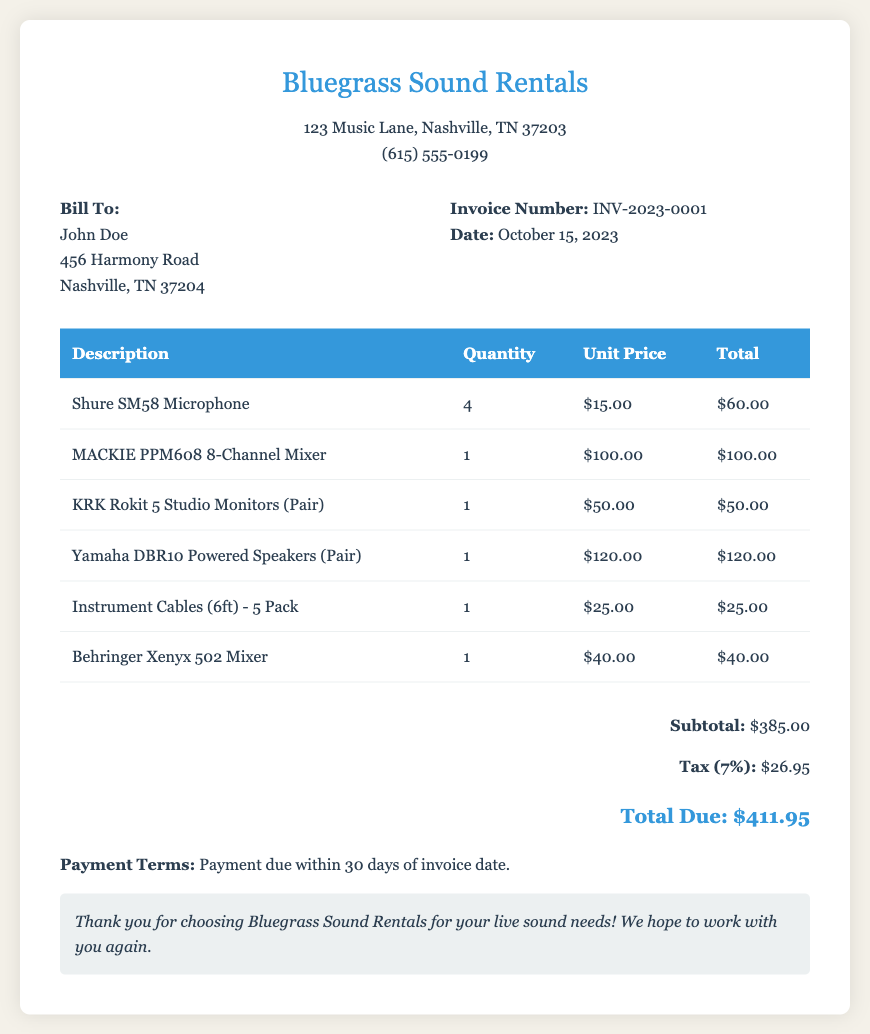What is the business name? The business name is prominently displayed at the top of the document.
Answer: Bluegrass Sound Rentals What is the invoice number? The invoice number is indicated in the invoice details section.
Answer: INV-2023-0001 What is the date of the invoice? The date is found alongside the invoice number in the invoice details section.
Answer: October 15, 2023 How many Shure SM58 Microphones were rented? This information is listed in the itemized charges table under quantity for Shure SM58 Microphone.
Answer: 4 What is the total due amount? The total due is calculated at the bottom of the invoice, summarizing all charges including tax.
Answer: $411.95 What is the tax rate applied to the subtotal? The tax rate is mentioned directly in relation to the subtotal within the totals section.
Answer: 7% What payment terms are specified? This information is usually listed towards the end of the invoice.
Answer: Payment due within 30 days of invoice date What type of item is the Behringer Xenyx 502? The type of item can be found in the description column of the table.
Answer: Mixer What is the subtotal amount before tax? The subtotal can be found in the totals section prior to the tax calculations.
Answer: $385.00 